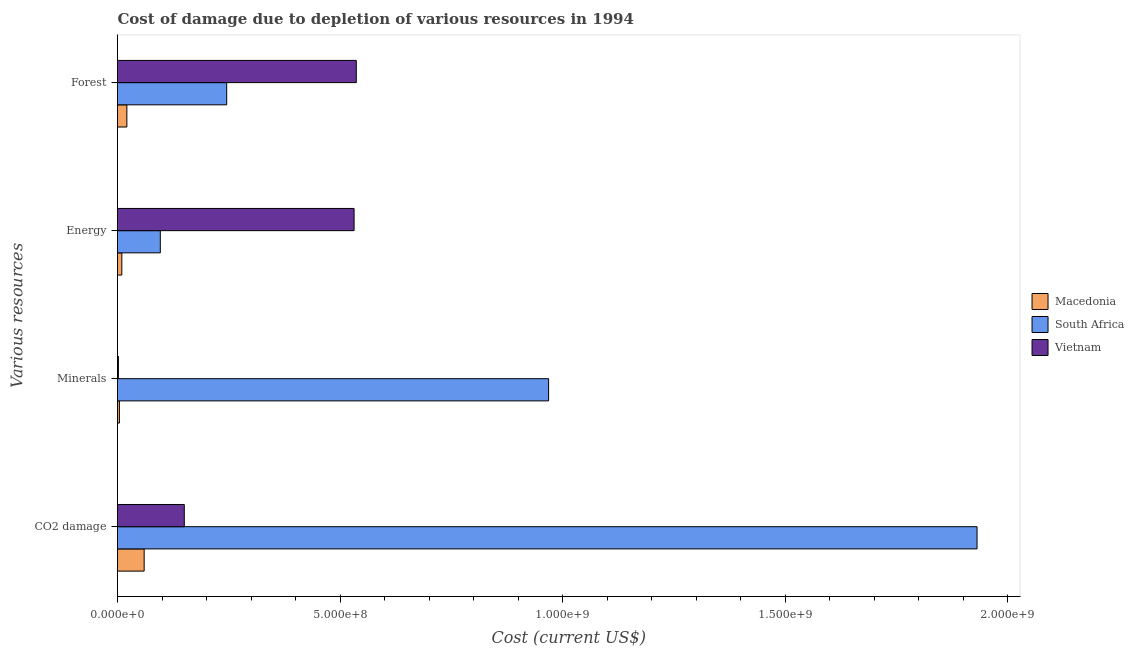How many groups of bars are there?
Provide a succinct answer. 4. Are the number of bars per tick equal to the number of legend labels?
Your answer should be very brief. Yes. Are the number of bars on each tick of the Y-axis equal?
Offer a terse response. Yes. What is the label of the 2nd group of bars from the top?
Your answer should be compact. Energy. What is the cost of damage due to depletion of coal in South Africa?
Your answer should be compact. 1.93e+09. Across all countries, what is the maximum cost of damage due to depletion of energy?
Ensure brevity in your answer.  5.32e+08. Across all countries, what is the minimum cost of damage due to depletion of forests?
Offer a very short reply. 2.10e+07. In which country was the cost of damage due to depletion of minerals maximum?
Give a very brief answer. South Africa. In which country was the cost of damage due to depletion of coal minimum?
Provide a succinct answer. Macedonia. What is the total cost of damage due to depletion of energy in the graph?
Your answer should be very brief. 6.38e+08. What is the difference between the cost of damage due to depletion of energy in South Africa and that in Vietnam?
Offer a very short reply. -4.35e+08. What is the difference between the cost of damage due to depletion of forests in South Africa and the cost of damage due to depletion of minerals in Macedonia?
Your answer should be compact. 2.41e+08. What is the average cost of damage due to depletion of forests per country?
Make the answer very short. 2.68e+08. What is the difference between the cost of damage due to depletion of forests and cost of damage due to depletion of minerals in Vietnam?
Give a very brief answer. 5.35e+08. What is the ratio of the cost of damage due to depletion of coal in Vietnam to that in Macedonia?
Your answer should be compact. 2.51. What is the difference between the highest and the second highest cost of damage due to depletion of forests?
Your answer should be very brief. 2.91e+08. What is the difference between the highest and the lowest cost of damage due to depletion of minerals?
Keep it short and to the point. 9.67e+08. What does the 3rd bar from the top in Forest represents?
Make the answer very short. Macedonia. What does the 2nd bar from the bottom in Forest represents?
Provide a succinct answer. South Africa. Is it the case that in every country, the sum of the cost of damage due to depletion of coal and cost of damage due to depletion of minerals is greater than the cost of damage due to depletion of energy?
Keep it short and to the point. No. Are all the bars in the graph horizontal?
Your response must be concise. Yes. How many countries are there in the graph?
Ensure brevity in your answer.  3. What is the difference between two consecutive major ticks on the X-axis?
Provide a succinct answer. 5.00e+08. Does the graph contain grids?
Your answer should be compact. No. Where does the legend appear in the graph?
Keep it short and to the point. Center right. How are the legend labels stacked?
Ensure brevity in your answer.  Vertical. What is the title of the graph?
Your response must be concise. Cost of damage due to depletion of various resources in 1994 . What is the label or title of the X-axis?
Offer a very short reply. Cost (current US$). What is the label or title of the Y-axis?
Your answer should be compact. Various resources. What is the Cost (current US$) in Macedonia in CO2 damage?
Give a very brief answer. 5.99e+07. What is the Cost (current US$) of South Africa in CO2 damage?
Give a very brief answer. 1.93e+09. What is the Cost (current US$) in Vietnam in CO2 damage?
Provide a short and direct response. 1.50e+08. What is the Cost (current US$) of Macedonia in Minerals?
Keep it short and to the point. 4.29e+06. What is the Cost (current US$) in South Africa in Minerals?
Ensure brevity in your answer.  9.69e+08. What is the Cost (current US$) of Vietnam in Minerals?
Offer a very short reply. 1.98e+06. What is the Cost (current US$) of Macedonia in Energy?
Your response must be concise. 9.71e+06. What is the Cost (current US$) of South Africa in Energy?
Your answer should be compact. 9.62e+07. What is the Cost (current US$) in Vietnam in Energy?
Your answer should be compact. 5.32e+08. What is the Cost (current US$) of Macedonia in Forest?
Your response must be concise. 2.10e+07. What is the Cost (current US$) in South Africa in Forest?
Offer a terse response. 2.45e+08. What is the Cost (current US$) in Vietnam in Forest?
Your answer should be very brief. 5.37e+08. Across all Various resources, what is the maximum Cost (current US$) in Macedonia?
Keep it short and to the point. 5.99e+07. Across all Various resources, what is the maximum Cost (current US$) in South Africa?
Ensure brevity in your answer.  1.93e+09. Across all Various resources, what is the maximum Cost (current US$) of Vietnam?
Your answer should be very brief. 5.37e+08. Across all Various resources, what is the minimum Cost (current US$) of Macedonia?
Make the answer very short. 4.29e+06. Across all Various resources, what is the minimum Cost (current US$) of South Africa?
Your answer should be very brief. 9.62e+07. Across all Various resources, what is the minimum Cost (current US$) in Vietnam?
Offer a terse response. 1.98e+06. What is the total Cost (current US$) of Macedonia in the graph?
Your answer should be compact. 9.49e+07. What is the total Cost (current US$) in South Africa in the graph?
Provide a short and direct response. 3.24e+09. What is the total Cost (current US$) of Vietnam in the graph?
Your response must be concise. 1.22e+09. What is the difference between the Cost (current US$) in Macedonia in CO2 damage and that in Minerals?
Offer a terse response. 5.56e+07. What is the difference between the Cost (current US$) of South Africa in CO2 damage and that in Minerals?
Provide a succinct answer. 9.63e+08. What is the difference between the Cost (current US$) of Vietnam in CO2 damage and that in Minerals?
Offer a terse response. 1.48e+08. What is the difference between the Cost (current US$) of Macedonia in CO2 damage and that in Energy?
Your answer should be very brief. 5.02e+07. What is the difference between the Cost (current US$) of South Africa in CO2 damage and that in Energy?
Your answer should be compact. 1.84e+09. What is the difference between the Cost (current US$) in Vietnam in CO2 damage and that in Energy?
Provide a short and direct response. -3.82e+08. What is the difference between the Cost (current US$) of Macedonia in CO2 damage and that in Forest?
Make the answer very short. 3.89e+07. What is the difference between the Cost (current US$) of South Africa in CO2 damage and that in Forest?
Your answer should be compact. 1.69e+09. What is the difference between the Cost (current US$) in Vietnam in CO2 damage and that in Forest?
Provide a succinct answer. -3.87e+08. What is the difference between the Cost (current US$) in Macedonia in Minerals and that in Energy?
Your answer should be compact. -5.42e+06. What is the difference between the Cost (current US$) of South Africa in Minerals and that in Energy?
Your response must be concise. 8.73e+08. What is the difference between the Cost (current US$) of Vietnam in Minerals and that in Energy?
Offer a very short reply. -5.30e+08. What is the difference between the Cost (current US$) in Macedonia in Minerals and that in Forest?
Offer a terse response. -1.67e+07. What is the difference between the Cost (current US$) in South Africa in Minerals and that in Forest?
Your answer should be very brief. 7.23e+08. What is the difference between the Cost (current US$) in Vietnam in Minerals and that in Forest?
Give a very brief answer. -5.35e+08. What is the difference between the Cost (current US$) of Macedonia in Energy and that in Forest?
Your answer should be compact. -1.13e+07. What is the difference between the Cost (current US$) in South Africa in Energy and that in Forest?
Your answer should be very brief. -1.49e+08. What is the difference between the Cost (current US$) of Vietnam in Energy and that in Forest?
Make the answer very short. -4.96e+06. What is the difference between the Cost (current US$) in Macedonia in CO2 damage and the Cost (current US$) in South Africa in Minerals?
Offer a very short reply. -9.09e+08. What is the difference between the Cost (current US$) in Macedonia in CO2 damage and the Cost (current US$) in Vietnam in Minerals?
Keep it short and to the point. 5.79e+07. What is the difference between the Cost (current US$) of South Africa in CO2 damage and the Cost (current US$) of Vietnam in Minerals?
Offer a very short reply. 1.93e+09. What is the difference between the Cost (current US$) in Macedonia in CO2 damage and the Cost (current US$) in South Africa in Energy?
Provide a succinct answer. -3.63e+07. What is the difference between the Cost (current US$) of Macedonia in CO2 damage and the Cost (current US$) of Vietnam in Energy?
Your answer should be very brief. -4.72e+08. What is the difference between the Cost (current US$) of South Africa in CO2 damage and the Cost (current US$) of Vietnam in Energy?
Offer a very short reply. 1.40e+09. What is the difference between the Cost (current US$) of Macedonia in CO2 damage and the Cost (current US$) of South Africa in Forest?
Keep it short and to the point. -1.85e+08. What is the difference between the Cost (current US$) in Macedonia in CO2 damage and the Cost (current US$) in Vietnam in Forest?
Provide a succinct answer. -4.77e+08. What is the difference between the Cost (current US$) of South Africa in CO2 damage and the Cost (current US$) of Vietnam in Forest?
Your answer should be very brief. 1.39e+09. What is the difference between the Cost (current US$) of Macedonia in Minerals and the Cost (current US$) of South Africa in Energy?
Your answer should be compact. -9.19e+07. What is the difference between the Cost (current US$) in Macedonia in Minerals and the Cost (current US$) in Vietnam in Energy?
Your answer should be compact. -5.27e+08. What is the difference between the Cost (current US$) in South Africa in Minerals and the Cost (current US$) in Vietnam in Energy?
Your response must be concise. 4.37e+08. What is the difference between the Cost (current US$) in Macedonia in Minerals and the Cost (current US$) in South Africa in Forest?
Your answer should be very brief. -2.41e+08. What is the difference between the Cost (current US$) of Macedonia in Minerals and the Cost (current US$) of Vietnam in Forest?
Ensure brevity in your answer.  -5.32e+08. What is the difference between the Cost (current US$) of South Africa in Minerals and the Cost (current US$) of Vietnam in Forest?
Give a very brief answer. 4.32e+08. What is the difference between the Cost (current US$) of Macedonia in Energy and the Cost (current US$) of South Africa in Forest?
Offer a very short reply. -2.36e+08. What is the difference between the Cost (current US$) of Macedonia in Energy and the Cost (current US$) of Vietnam in Forest?
Give a very brief answer. -5.27e+08. What is the difference between the Cost (current US$) of South Africa in Energy and the Cost (current US$) of Vietnam in Forest?
Keep it short and to the point. -4.40e+08. What is the average Cost (current US$) of Macedonia per Various resources?
Give a very brief answer. 2.37e+07. What is the average Cost (current US$) in South Africa per Various resources?
Offer a terse response. 8.10e+08. What is the average Cost (current US$) of Vietnam per Various resources?
Your response must be concise. 3.05e+08. What is the difference between the Cost (current US$) in Macedonia and Cost (current US$) in South Africa in CO2 damage?
Provide a succinct answer. -1.87e+09. What is the difference between the Cost (current US$) in Macedonia and Cost (current US$) in Vietnam in CO2 damage?
Your answer should be very brief. -9.02e+07. What is the difference between the Cost (current US$) of South Africa and Cost (current US$) of Vietnam in CO2 damage?
Ensure brevity in your answer.  1.78e+09. What is the difference between the Cost (current US$) in Macedonia and Cost (current US$) in South Africa in Minerals?
Your answer should be compact. -9.64e+08. What is the difference between the Cost (current US$) in Macedonia and Cost (current US$) in Vietnam in Minerals?
Your response must be concise. 2.31e+06. What is the difference between the Cost (current US$) in South Africa and Cost (current US$) in Vietnam in Minerals?
Your answer should be very brief. 9.67e+08. What is the difference between the Cost (current US$) of Macedonia and Cost (current US$) of South Africa in Energy?
Make the answer very short. -8.65e+07. What is the difference between the Cost (current US$) of Macedonia and Cost (current US$) of Vietnam in Energy?
Provide a succinct answer. -5.22e+08. What is the difference between the Cost (current US$) of South Africa and Cost (current US$) of Vietnam in Energy?
Keep it short and to the point. -4.35e+08. What is the difference between the Cost (current US$) in Macedonia and Cost (current US$) in South Africa in Forest?
Provide a succinct answer. -2.24e+08. What is the difference between the Cost (current US$) of Macedonia and Cost (current US$) of Vietnam in Forest?
Your response must be concise. -5.16e+08. What is the difference between the Cost (current US$) in South Africa and Cost (current US$) in Vietnam in Forest?
Offer a very short reply. -2.91e+08. What is the ratio of the Cost (current US$) in Macedonia in CO2 damage to that in Minerals?
Your response must be concise. 13.98. What is the ratio of the Cost (current US$) in South Africa in CO2 damage to that in Minerals?
Offer a very short reply. 1.99. What is the ratio of the Cost (current US$) of Vietnam in CO2 damage to that in Minerals?
Your answer should be very brief. 75.9. What is the ratio of the Cost (current US$) in Macedonia in CO2 damage to that in Energy?
Your answer should be very brief. 6.17. What is the ratio of the Cost (current US$) of South Africa in CO2 damage to that in Energy?
Ensure brevity in your answer.  20.08. What is the ratio of the Cost (current US$) of Vietnam in CO2 damage to that in Energy?
Provide a succinct answer. 0.28. What is the ratio of the Cost (current US$) of Macedonia in CO2 damage to that in Forest?
Your answer should be compact. 2.85. What is the ratio of the Cost (current US$) in South Africa in CO2 damage to that in Forest?
Your response must be concise. 7.87. What is the ratio of the Cost (current US$) in Vietnam in CO2 damage to that in Forest?
Keep it short and to the point. 0.28. What is the ratio of the Cost (current US$) in Macedonia in Minerals to that in Energy?
Offer a very short reply. 0.44. What is the ratio of the Cost (current US$) in South Africa in Minerals to that in Energy?
Your answer should be compact. 10.07. What is the ratio of the Cost (current US$) of Vietnam in Minerals to that in Energy?
Provide a short and direct response. 0. What is the ratio of the Cost (current US$) of Macedonia in Minerals to that in Forest?
Ensure brevity in your answer.  0.2. What is the ratio of the Cost (current US$) of South Africa in Minerals to that in Forest?
Offer a very short reply. 3.95. What is the ratio of the Cost (current US$) in Vietnam in Minerals to that in Forest?
Ensure brevity in your answer.  0. What is the ratio of the Cost (current US$) in Macedonia in Energy to that in Forest?
Make the answer very short. 0.46. What is the ratio of the Cost (current US$) of South Africa in Energy to that in Forest?
Give a very brief answer. 0.39. What is the difference between the highest and the second highest Cost (current US$) of Macedonia?
Keep it short and to the point. 3.89e+07. What is the difference between the highest and the second highest Cost (current US$) in South Africa?
Your answer should be compact. 9.63e+08. What is the difference between the highest and the second highest Cost (current US$) in Vietnam?
Provide a short and direct response. 4.96e+06. What is the difference between the highest and the lowest Cost (current US$) in Macedonia?
Give a very brief answer. 5.56e+07. What is the difference between the highest and the lowest Cost (current US$) in South Africa?
Provide a succinct answer. 1.84e+09. What is the difference between the highest and the lowest Cost (current US$) in Vietnam?
Ensure brevity in your answer.  5.35e+08. 